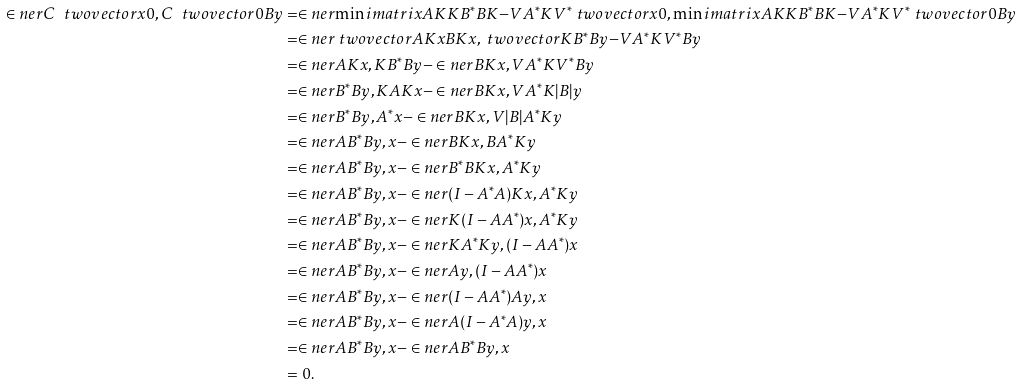<formula> <loc_0><loc_0><loc_500><loc_500>\in n e r { C \ t w o v e c t o r { x } { 0 } , C \ t w o v e c t o r { 0 } { B y } } & = \in n e r { \min i m a t r i x { A K } { K B ^ { * } } { B K } { - V A ^ { * } K V ^ { * } } \ t w o v e c t o r { x } { 0 } , \min i m a t r i x { A K } { K B ^ { * } } { B K } { - V A ^ { * } K V ^ { * } } \ t w o v e c t o r { 0 } { B y } } \\ & = \in n e r { \ t w o v e c t o r { A K x } { B K x } , \ t w o v e c t o r { K B ^ { * } B y } { - V A ^ { * } K V ^ { * } B y } } \\ & = \in n e r { A K x , K B ^ { * } B y } - \in n e r { B K x , V A ^ { * } K V ^ { * } B y } \\ & = \in n e r { B ^ { * } B y , K A K x } - \in n e r { B K x , V A ^ { * } K | B | y } \\ & = \in n e r { B ^ { * } B y , A ^ { * } x } - \in n e r { B K x , V | B | A ^ { * } K y } \\ & = \in n e r { A B ^ { * } B y , x } - \in n e r { B K x , B A ^ { * } K y } \\ & = \in n e r { A B ^ { * } B y , x } - \in n e r { B ^ { * } B K x , A ^ { * } K y } \\ & = \in n e r { A B ^ { * } B y , x } - \in n e r { ( I - A ^ { * } A ) K x , A ^ { * } K y } \\ & = \in n e r { A B ^ { * } B y , x } - \in n e r { K ( I - A A ^ { * } ) x , A ^ { * } K y } \\ & = \in n e r { A B ^ { * } B y , x } - \in n e r { K A ^ { * } K y , ( I - A A ^ { * } ) x } \\ & = \in n e r { A B ^ { * } B y , x } - \in n e r { A y , ( I - A A ^ { * } ) x } \\ & = \in n e r { A B ^ { * } B y , x } - \in n e r { ( I - A A ^ { * } ) A y , x } \\ & = \in n e r { A B ^ { * } B y , x } - \in n e r { A ( I - A ^ { * } A ) y , x } \\ & = \in n e r { A B ^ { * } B y , x } - \in n e r { A B ^ { * } B y , x } \\ & = 0 .</formula> 